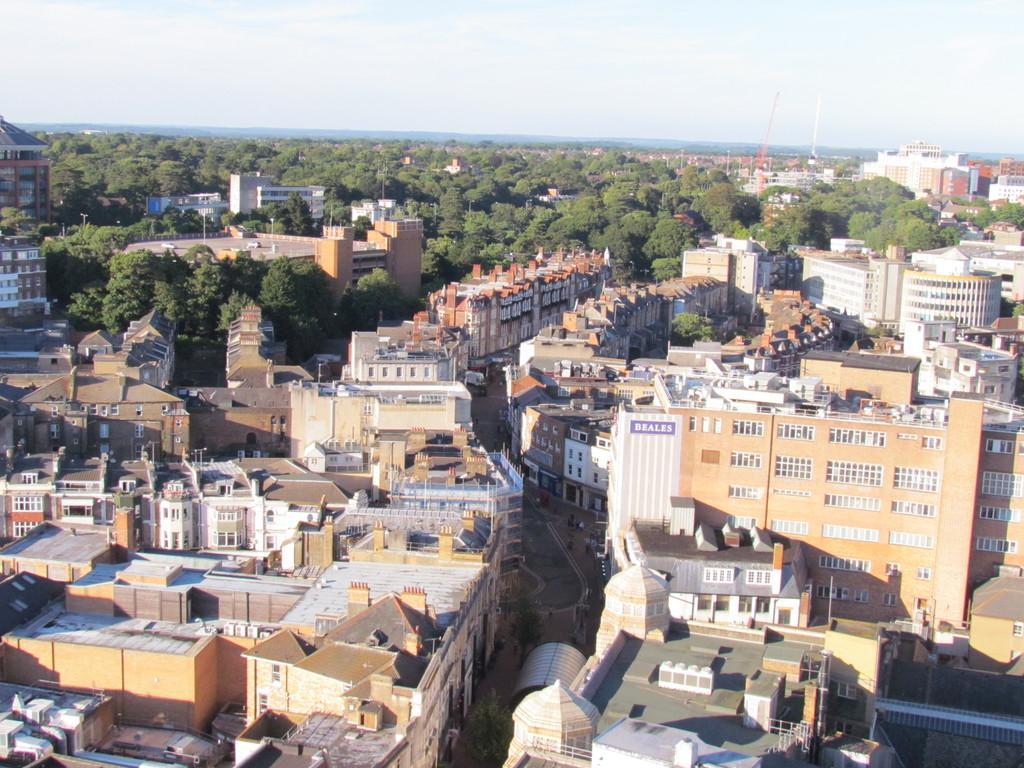In one or two sentences, can you explain what this image depicts? In this image I can see some people and the vehicles on the road. I can see the buildings. In the background, I can see the trees and clouds in the sky. 